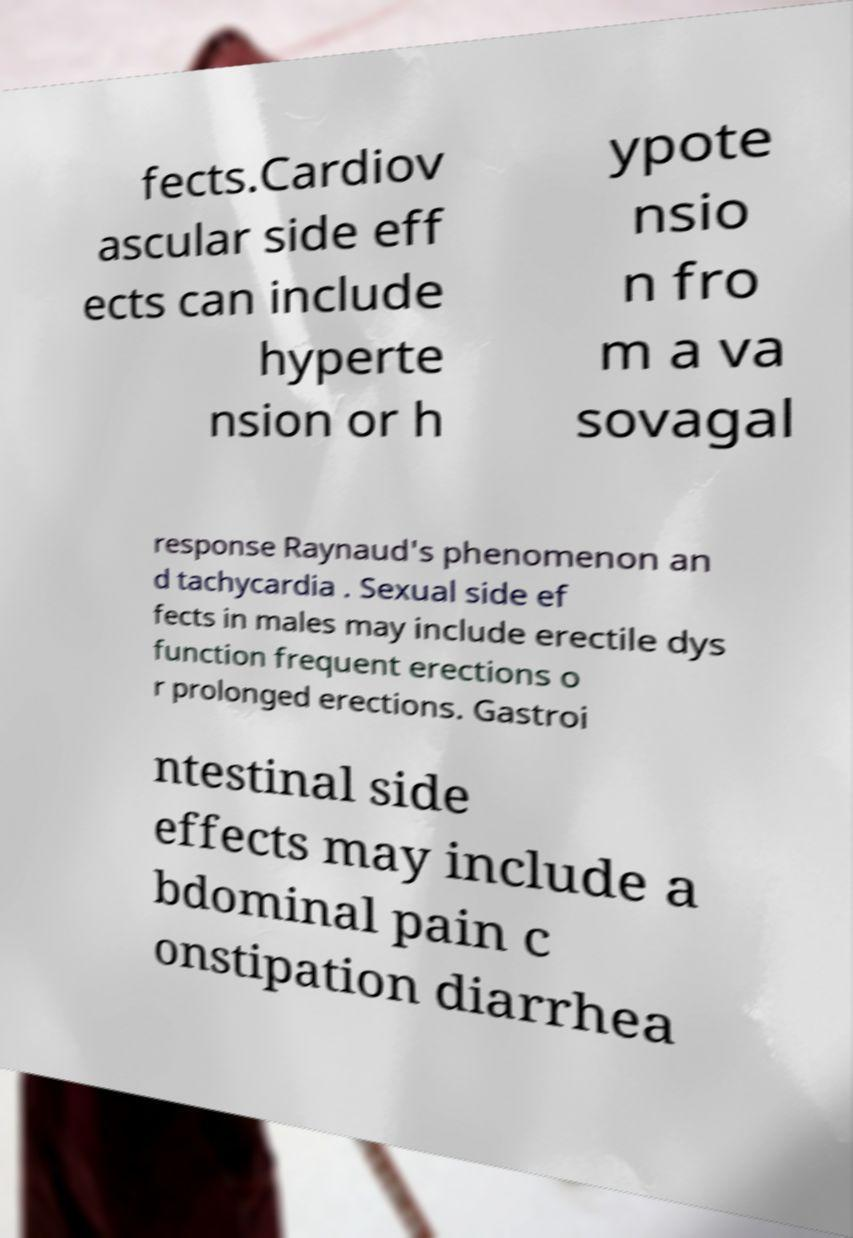What messages or text are displayed in this image? I need them in a readable, typed format. fects.Cardiov ascular side eff ects can include hyperte nsion or h ypote nsio n fro m a va sovagal response Raynaud's phenomenon an d tachycardia . Sexual side ef fects in males may include erectile dys function frequent erections o r prolonged erections. Gastroi ntestinal side effects may include a bdominal pain c onstipation diarrhea 